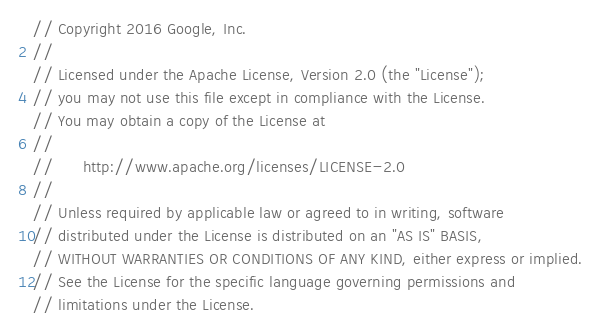<code> <loc_0><loc_0><loc_500><loc_500><_Go_>// Copyright 2016 Google, Inc.
//
// Licensed under the Apache License, Version 2.0 (the "License");
// you may not use this file except in compliance with the License.
// You may obtain a copy of the License at
//
//      http://www.apache.org/licenses/LICENSE-2.0
//
// Unless required by applicable law or agreed to in writing, software
// distributed under the License is distributed on an "AS IS" BASIS,
// WITHOUT WARRANTIES OR CONDITIONS OF ANY KIND, either express or implied.
// See the License for the specific language governing permissions and
// limitations under the License.
</code> 